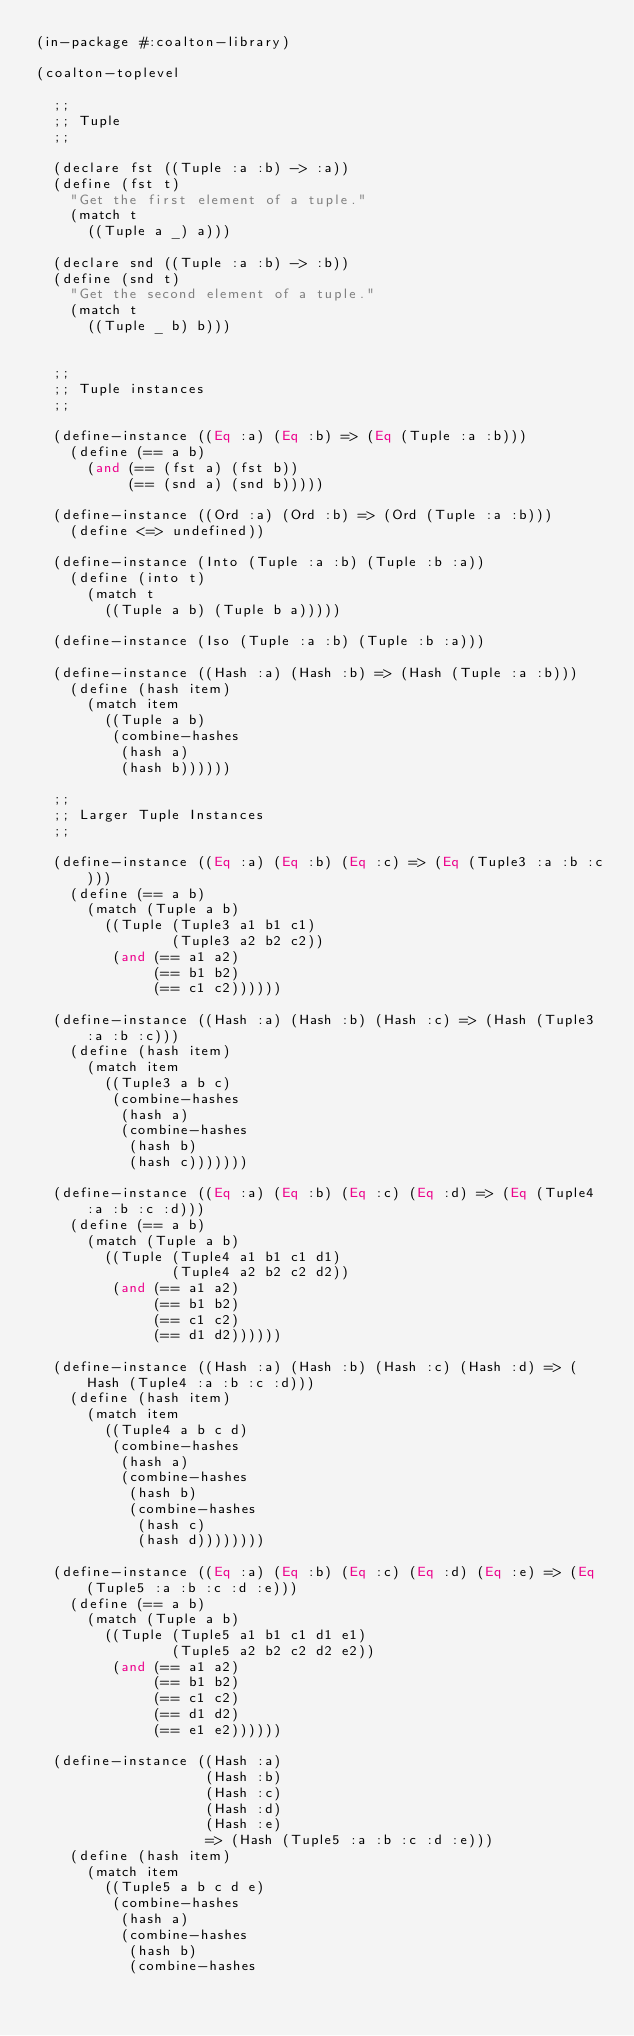<code> <loc_0><loc_0><loc_500><loc_500><_Lisp_>(in-package #:coalton-library)

(coalton-toplevel

  ;;
  ;; Tuple
  ;;

  (declare fst ((Tuple :a :b) -> :a))
  (define (fst t)
    "Get the first element of a tuple."
    (match t
      ((Tuple a _) a)))

  (declare snd ((Tuple :a :b) -> :b))
  (define (snd t)
    "Get the second element of a tuple."
    (match t
      ((Tuple _ b) b)))


  ;;
  ;; Tuple instances
  ;;

  (define-instance ((Eq :a) (Eq :b) => (Eq (Tuple :a :b)))
    (define (== a b)
      (and (== (fst a) (fst b))
           (== (snd a) (snd b)))))

  (define-instance ((Ord :a) (Ord :b) => (Ord (Tuple :a :b)))
    (define <=> undefined))

  (define-instance (Into (Tuple :a :b) (Tuple :b :a))
    (define (into t)
      (match t
        ((Tuple a b) (Tuple b a)))))

  (define-instance (Iso (Tuple :a :b) (Tuple :b :a)))

  (define-instance ((Hash :a) (Hash :b) => (Hash (Tuple :a :b)))
    (define (hash item)
      (match item
        ((Tuple a b)
         (combine-hashes
          (hash a)
          (hash b))))))

  ;;
  ;; Larger Tuple Instances
  ;;

  (define-instance ((Eq :a) (Eq :b) (Eq :c) => (Eq (Tuple3 :a :b :c)))
    (define (== a b)
      (match (Tuple a b)
        ((Tuple (Tuple3 a1 b1 c1)
                (Tuple3 a2 b2 c2))
         (and (== a1 a2)
              (== b1 b2)
              (== c1 c2))))))

  (define-instance ((Hash :a) (Hash :b) (Hash :c) => (Hash (Tuple3 :a :b :c)))
    (define (hash item)
      (match item
        ((Tuple3 a b c)
         (combine-hashes
          (hash a)
          (combine-hashes
           (hash b)
           (hash c)))))))

  (define-instance ((Eq :a) (Eq :b) (Eq :c) (Eq :d) => (Eq (Tuple4 :a :b :c :d)))
    (define (== a b)
      (match (Tuple a b)
        ((Tuple (Tuple4 a1 b1 c1 d1)
                (Tuple4 a2 b2 c2 d2))
         (and (== a1 a2)
              (== b1 b2)
              (== c1 c2)
              (== d1 d2))))))

  (define-instance ((Hash :a) (Hash :b) (Hash :c) (Hash :d) => (Hash (Tuple4 :a :b :c :d)))
    (define (hash item)
      (match item
        ((Tuple4 a b c d)
         (combine-hashes
          (hash a)
          (combine-hashes
           (hash b)
           (combine-hashes
            (hash c)
            (hash d))))))))

  (define-instance ((Eq :a) (Eq :b) (Eq :c) (Eq :d) (Eq :e) => (Eq (Tuple5 :a :b :c :d :e)))
    (define (== a b)
      (match (Tuple a b)
        ((Tuple (Tuple5 a1 b1 c1 d1 e1)
                (Tuple5 a2 b2 c2 d2 e2))
         (and (== a1 a2)
              (== b1 b2)
              (== c1 c2)
              (== d1 d2)
              (== e1 e2))))))

  (define-instance ((Hash :a)
                    (Hash :b)
                    (Hash :c)
                    (Hash :d)
                    (Hash :e)
                    => (Hash (Tuple5 :a :b :c :d :e)))
    (define (hash item)
      (match item
        ((Tuple5 a b c d e)
         (combine-hashes
          (hash a)
          (combine-hashes
           (hash b)
           (combine-hashes</code> 